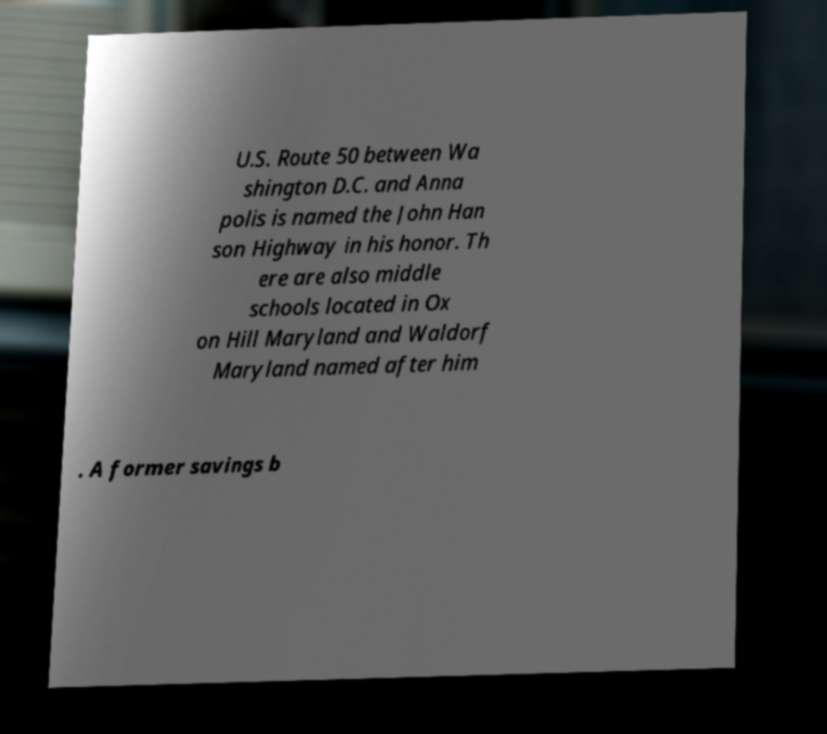Please read and relay the text visible in this image. What does it say? U.S. Route 50 between Wa shington D.C. and Anna polis is named the John Han son Highway in his honor. Th ere are also middle schools located in Ox on Hill Maryland and Waldorf Maryland named after him . A former savings b 